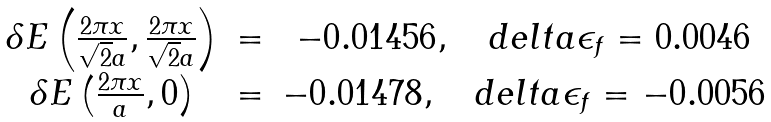Convert formula to latex. <formula><loc_0><loc_0><loc_500><loc_500>\begin{array} { c c c } \delta E \left ( \frac { 2 \pi x } { \sqrt { 2 } a } , \frac { 2 \pi x } { \sqrt { 2 } a } \right ) & = & - 0 . 0 1 4 5 6 , \quad d e l t a \epsilon _ { f } = 0 . 0 0 4 6 \\ \delta E \left ( \frac { 2 \pi x } { a } , 0 \right ) & = & - 0 . 0 1 4 7 8 , \quad d e l t a \epsilon _ { f } = - 0 . 0 0 5 6 \\ \end{array}</formula> 